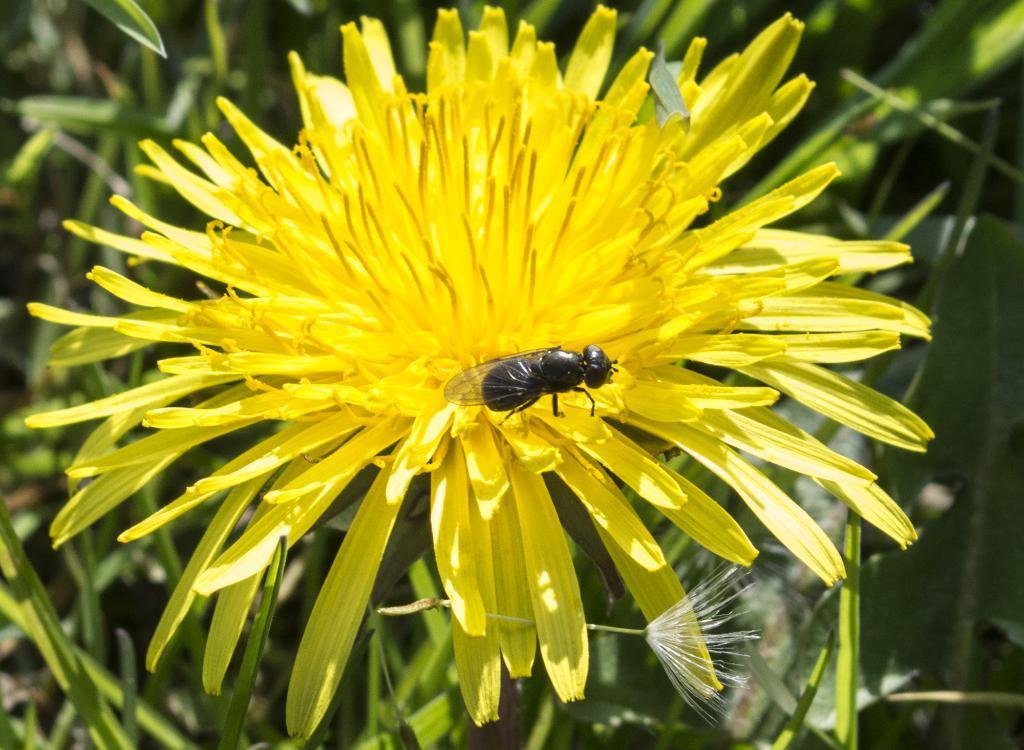Describe this image in one or two sentences. In the foreground of the picture there is a flower, on the flower there is a fly. In the background there is greenery. 